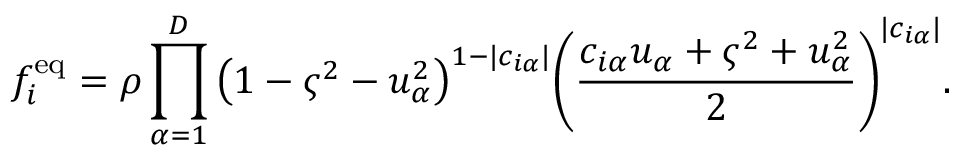<formula> <loc_0><loc_0><loc_500><loc_500>f _ { i } ^ { e q } = \rho \prod _ { \alpha = 1 } ^ { D } { \left ( 1 - \varsigma ^ { 2 } - u _ { \alpha } ^ { 2 } \right ) } ^ { 1 - | c _ { i \alpha } | } { \left ( \frac { c _ { i \alpha } u _ { \alpha } + \varsigma ^ { 2 } + u _ { \alpha } ^ { 2 } } { 2 } \right ) } ^ { | c _ { i \alpha } | } .</formula> 